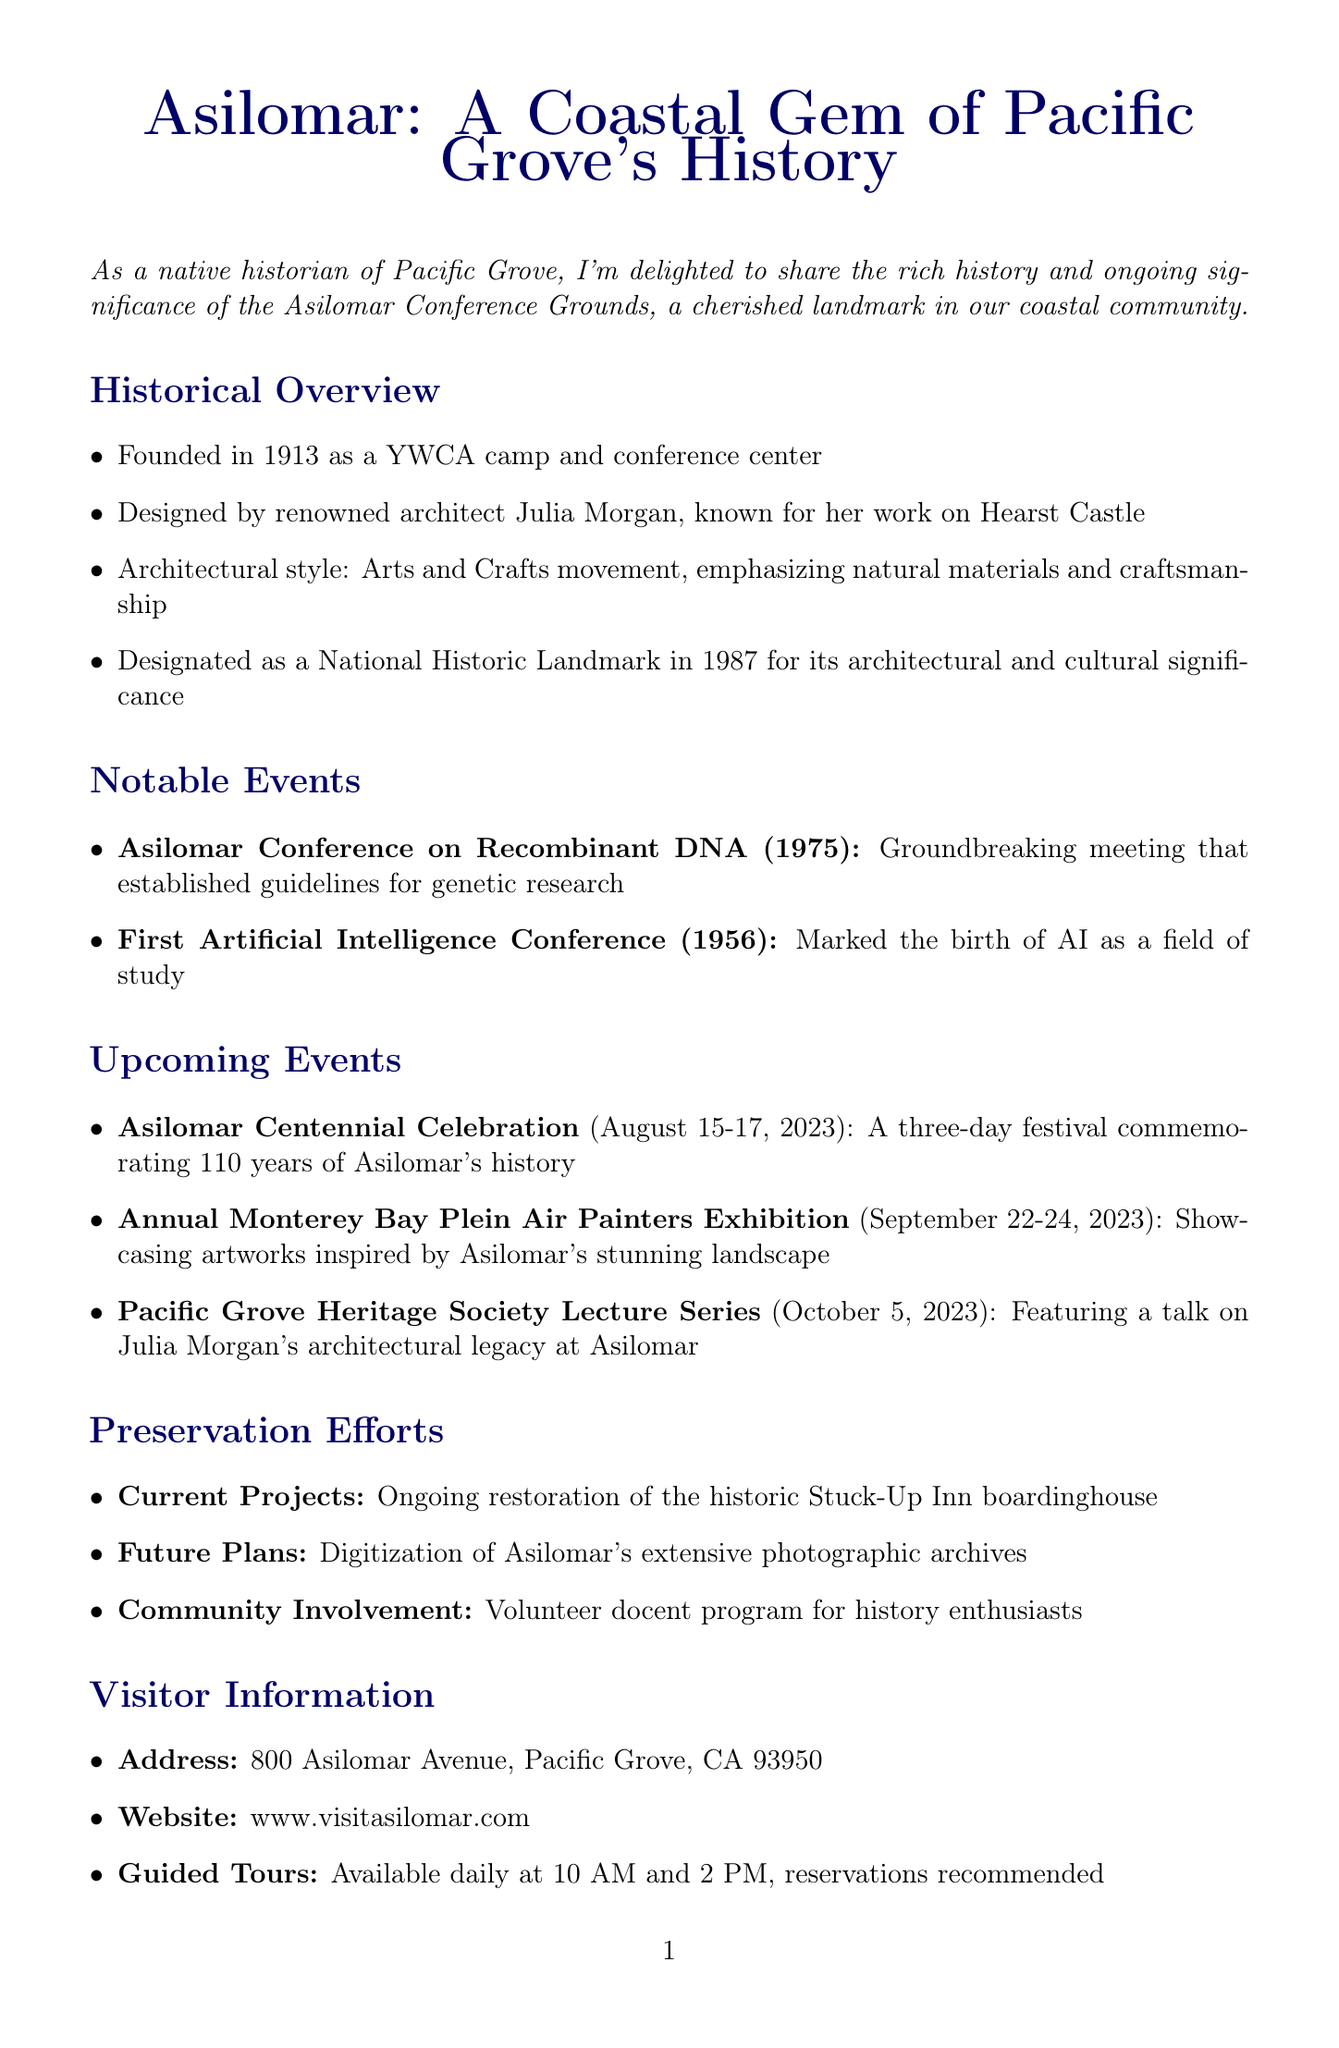What year was Asilomar founded? The year of establishment for Asilomar is mentioned in the historical overview section.
Answer: 1913 Who designed Asilomar? The architect's name is provided in the document within the historical overview.
Answer: Julia Morgan What architectural style is Asilomar associated with? The architectural style is listed in the historical overview of the document.
Answer: Arts and Crafts movement When was the Asilomar Conference on Recombinant DNA held? The date of this significant event is found in the notable events section.
Answer: 1975 What is a current preservation project at Asilomar? The document specifies current projects under preservation efforts.
Answer: Restoration of the historic Stuck-Up Inn boardinghouse How long is the upcoming Asilomar Centennial Celebration? The duration of the event is stated in the upcoming events section.
Answer: Three days What is the address of Asilomar? The visitor information section contains the address of Asilomar.
Answer: 800 Asilomar Avenue, Pacific Grove, CA 93950 What event is scheduled for October 5, 2023? The upcoming events section provides the specific name of this lecture series.
Answer: Pacific Grove Heritage Society Lecture Series 